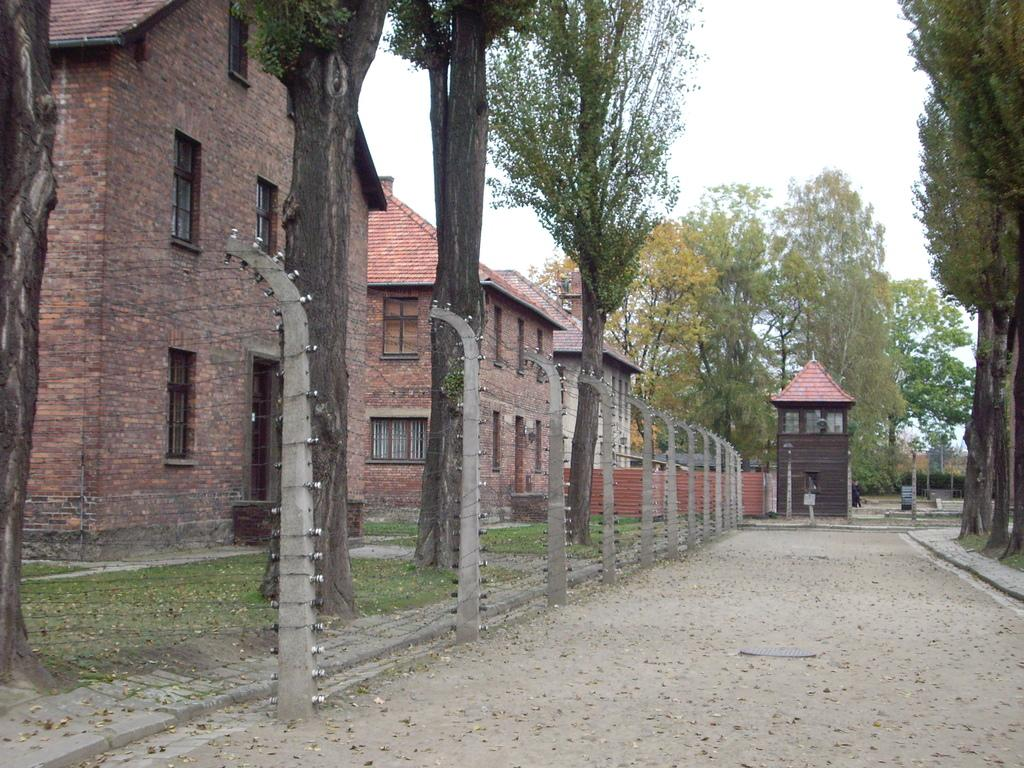What type of terrain is visible in the image? There is sand in the image. What type of infrastructure is present in the image? There is a road, buildings, and street lights in the image. What type of vegetation is visible in the image? There are trees in the image. What is visible in the sky in the image? There is a sky visible in the image. Is there any human presence in the image? Yes, there is a person in the image. How many sheep can be seen grazing on the sand in the image? There are no sheep present in the image; it features sand, a road, trees, buildings, street lights, sky, and a person. What type of flesh is visible on the person in the image? There is no flesh visible on the person in the image; the person is fully clothed. 